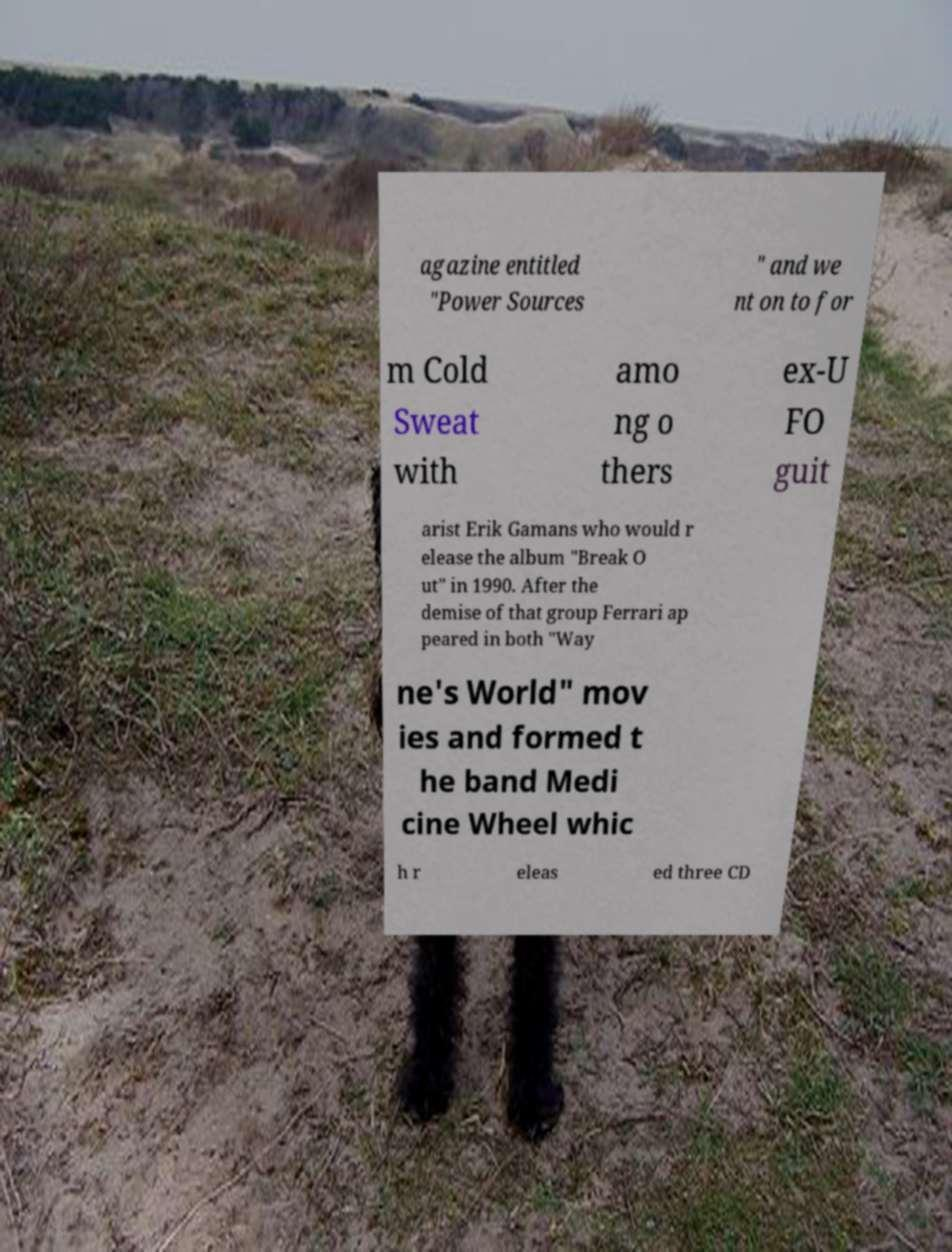Could you extract and type out the text from this image? agazine entitled "Power Sources " and we nt on to for m Cold Sweat with amo ng o thers ex-U FO guit arist Erik Gamans who would r elease the album "Break O ut" in 1990. After the demise of that group Ferrari ap peared in both "Way ne's World" mov ies and formed t he band Medi cine Wheel whic h r eleas ed three CD 